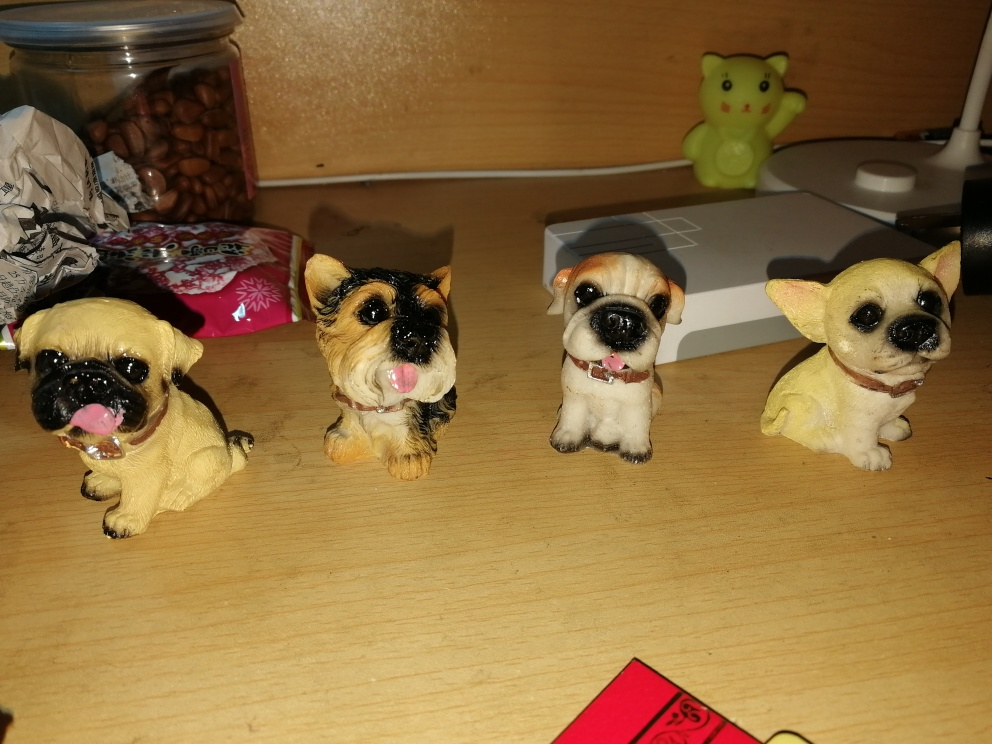Describe the setting these figurines are placed in. The figurines are arranged neatly on a wood-textured surface that appears to be a desk or tabletop, illuminated by a warm, ambient light. In the background, there are various items such as a jar of almonds, a green toy frog, and an assortment of objects which include what seems to be packaging material and a technology box, creating a casual and lived-in atmosphere. 